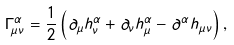<formula> <loc_0><loc_0><loc_500><loc_500>\Gamma ^ { \alpha } _ { \mu \nu } = \frac { 1 } { 2 } \left ( \partial _ { \mu } h _ { \nu } ^ { \alpha } + \partial _ { \nu } h ^ { \alpha } _ { \mu } - \partial ^ { \alpha } h _ { \mu \nu } \right ) ,</formula> 